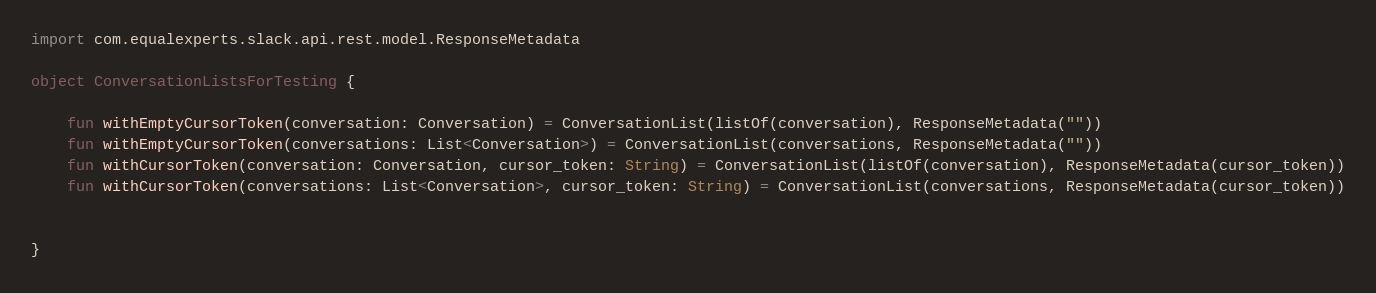Convert code to text. <code><loc_0><loc_0><loc_500><loc_500><_Kotlin_>import com.equalexperts.slack.api.rest.model.ResponseMetadata

object ConversationListsForTesting {

    fun withEmptyCursorToken(conversation: Conversation) = ConversationList(listOf(conversation), ResponseMetadata(""))
    fun withEmptyCursorToken(conversations: List<Conversation>) = ConversationList(conversations, ResponseMetadata(""))
    fun withCursorToken(conversation: Conversation, cursor_token: String) = ConversationList(listOf(conversation), ResponseMetadata(cursor_token))
    fun withCursorToken(conversations: List<Conversation>, cursor_token: String) = ConversationList(conversations, ResponseMetadata(cursor_token))


}</code> 